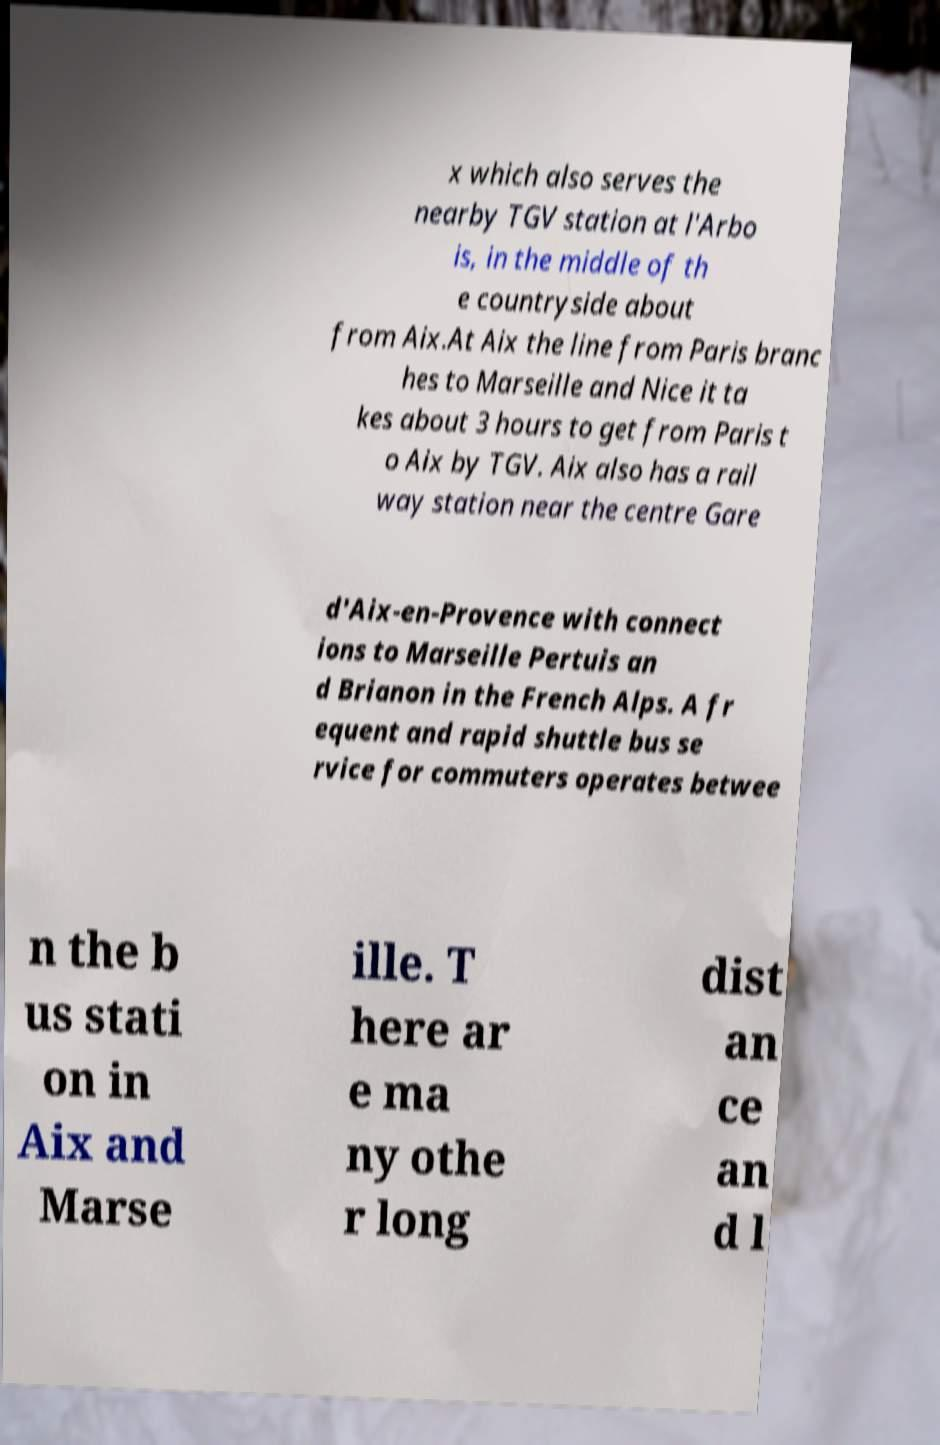For documentation purposes, I need the text within this image transcribed. Could you provide that? x which also serves the nearby TGV station at l'Arbo is, in the middle of th e countryside about from Aix.At Aix the line from Paris branc hes to Marseille and Nice it ta kes about 3 hours to get from Paris t o Aix by TGV. Aix also has a rail way station near the centre Gare d'Aix-en-Provence with connect ions to Marseille Pertuis an d Brianon in the French Alps. A fr equent and rapid shuttle bus se rvice for commuters operates betwee n the b us stati on in Aix and Marse ille. T here ar e ma ny othe r long dist an ce an d l 